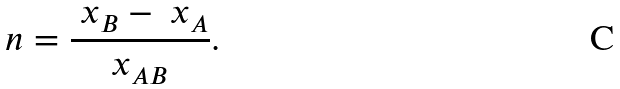Convert formula to latex. <formula><loc_0><loc_0><loc_500><loc_500>\ n = \frac { \ x _ { B } - \ x _ { A } } { x _ { A B } } .</formula> 